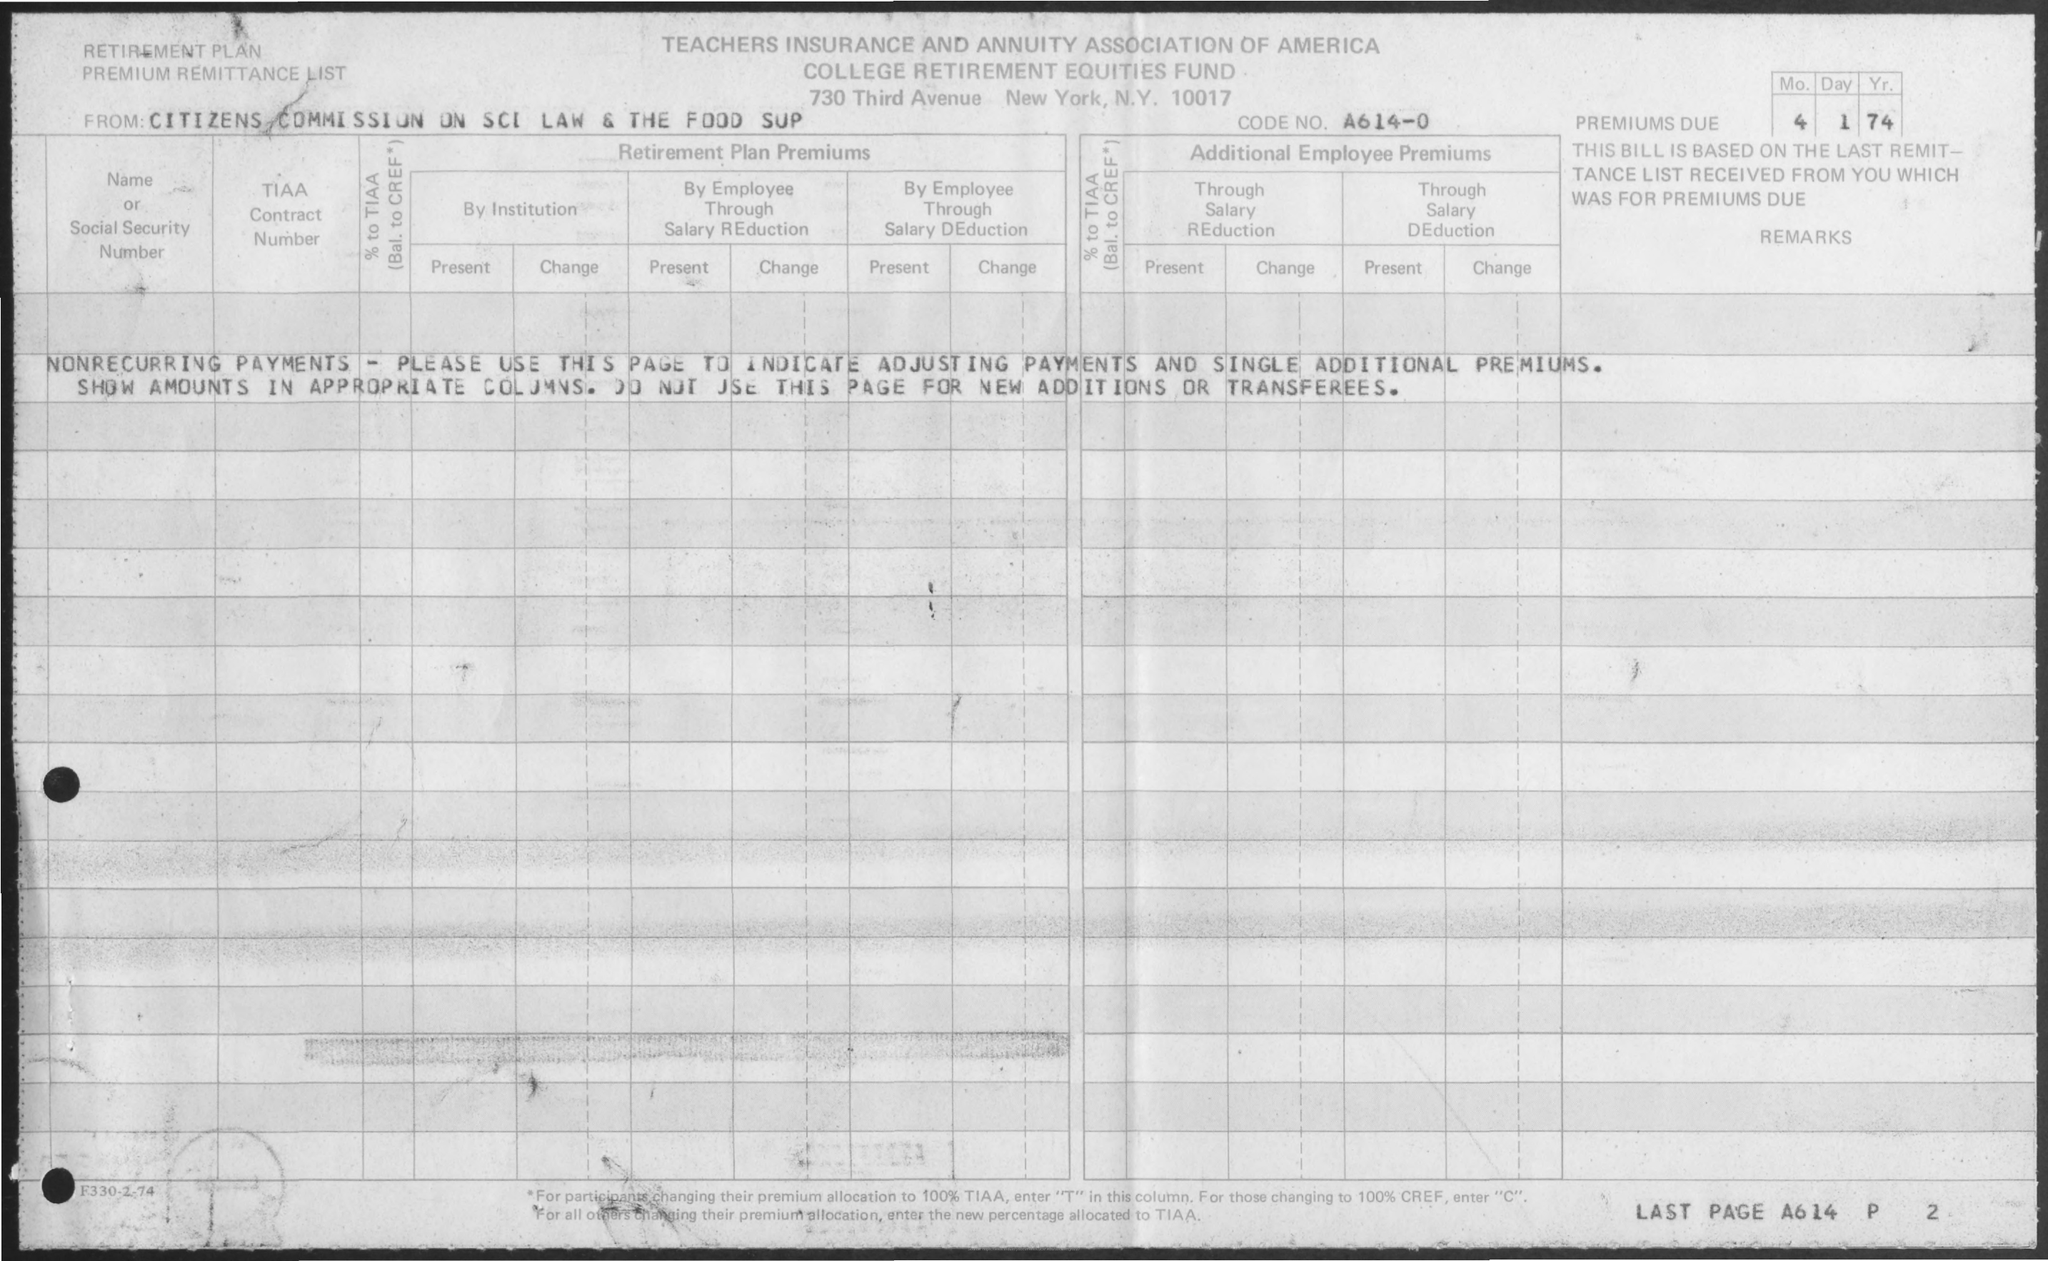What would the date indicate about the timespan of this document? The date on the document is marked as 4 1 74, which suggests it was issued on the 1st of April, 1974. This indicates that the form relates to financial contributions or adjustments required for that time period, reflecting the financial practices and pension management of that era. How does the document reflect the practices of that time? Retirement plans in the 1970s were often managed through detailed paper documentation like this. Contributions were tracked through institutional and employee payments, highlighting the collective effort in funding retirement, a practice indicative of the robust pension systems of the time, prior to more modern, digitized methods of financial management. 